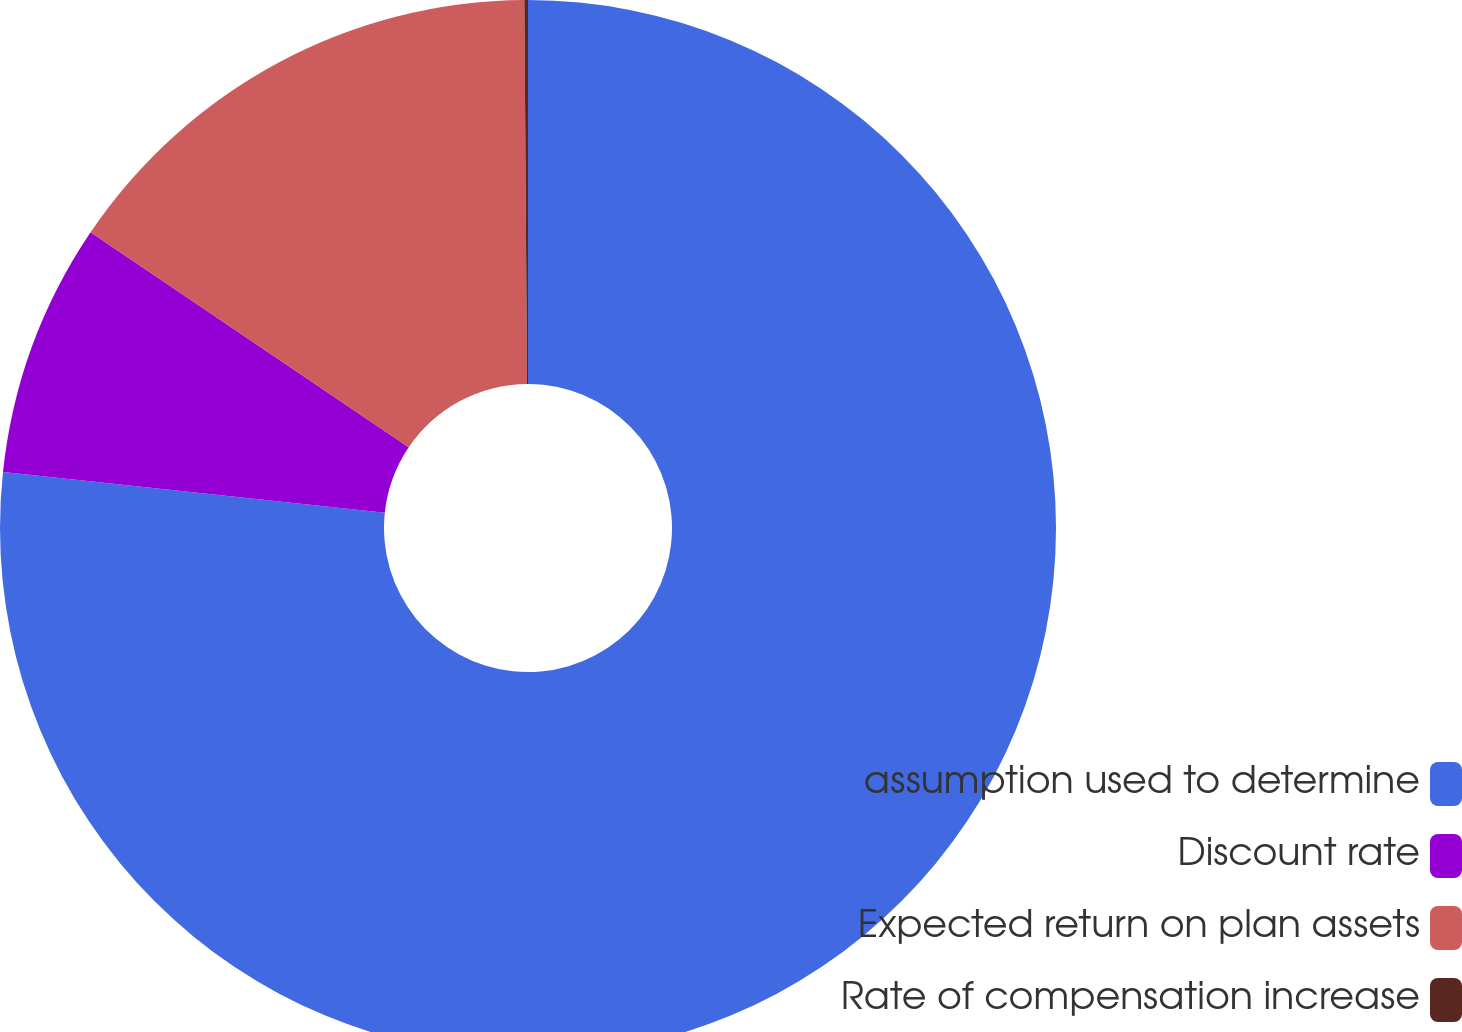Convert chart to OTSL. <chart><loc_0><loc_0><loc_500><loc_500><pie_chart><fcel>assumption used to determine<fcel>Discount rate<fcel>Expected return on plan assets<fcel>Rate of compensation increase<nl><fcel>76.7%<fcel>7.77%<fcel>15.43%<fcel>0.11%<nl></chart> 